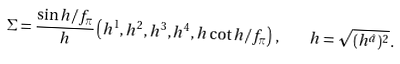Convert formula to latex. <formula><loc_0><loc_0><loc_500><loc_500>\Sigma = \frac { \sin h / f _ { \pi } } { h } \left ( h ^ { 1 } , h ^ { 2 } , h ^ { 3 } , h ^ { 4 } , h \cot h / f _ { \pi } \right ) \, , \quad h = \sqrt { ( h ^ { \hat { a } } ) ^ { 2 } } \, .</formula> 